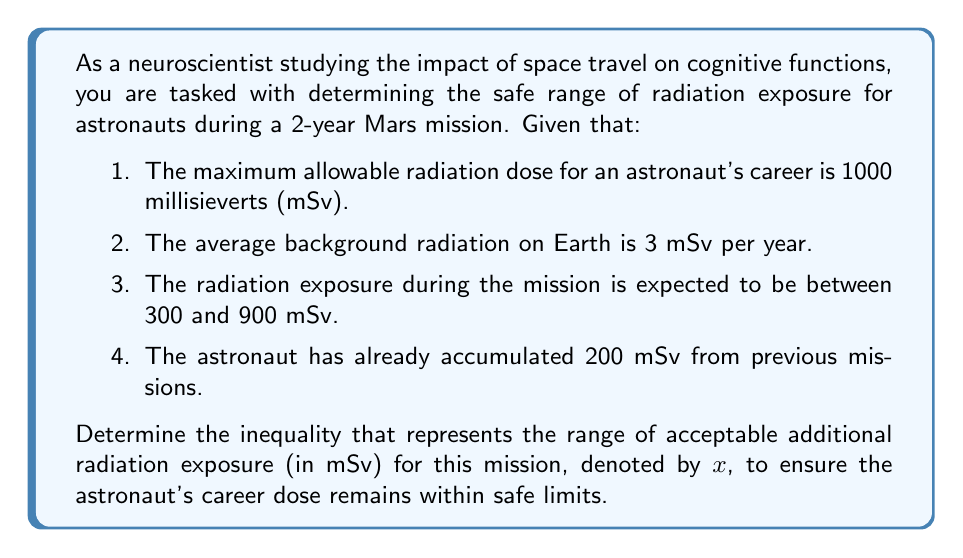Could you help me with this problem? Let's approach this step-by-step:

1) First, we need to calculate the total allowable additional radiation exposure for the astronaut:
   
   Maximum career dose - Already accumulated dose = Allowable additional dose
   $1000 \text{ mSv} - 200 \text{ mSv} = 800 \text{ mSv}$

2) Now, we need to account for the background radiation on Earth that the astronaut would have been exposed to if they hadn't gone on the mission:
   
   Background radiation for 2 years = $3 \text{ mSv/year} \times 2 \text{ years} = 6 \text{ mSv}$

3) This means the actual allowable additional dose from the mission is:
   
   $800 \text{ mSv} - 6 \text{ mSv} = 794 \text{ mSv}$

4) We're told that the radiation exposure during the mission is expected to be between 300 and 900 mSv. Let's call the actual exposure $x$. This gives us our first inequality:

   $300 \leq x \leq 900$

5) However, we also need to ensure that $x$ doesn't exceed our calculated allowable additional dose of 794 mSv:

   $x \leq 794$

6) Combining these conditions, we get:

   $300 \leq x \leq \min(900, 794) = 794$

Therefore, the final inequality is:

$$300 \leq x \leq 794$$

This inequality represents the range of acceptable additional radiation exposure (in mSv) for this mission, ensuring the astronaut's career dose remains within safe limits.
Answer: $300 \leq x \leq 794$, where $x$ represents the additional radiation exposure in millisieverts (mSv) for this mission. 